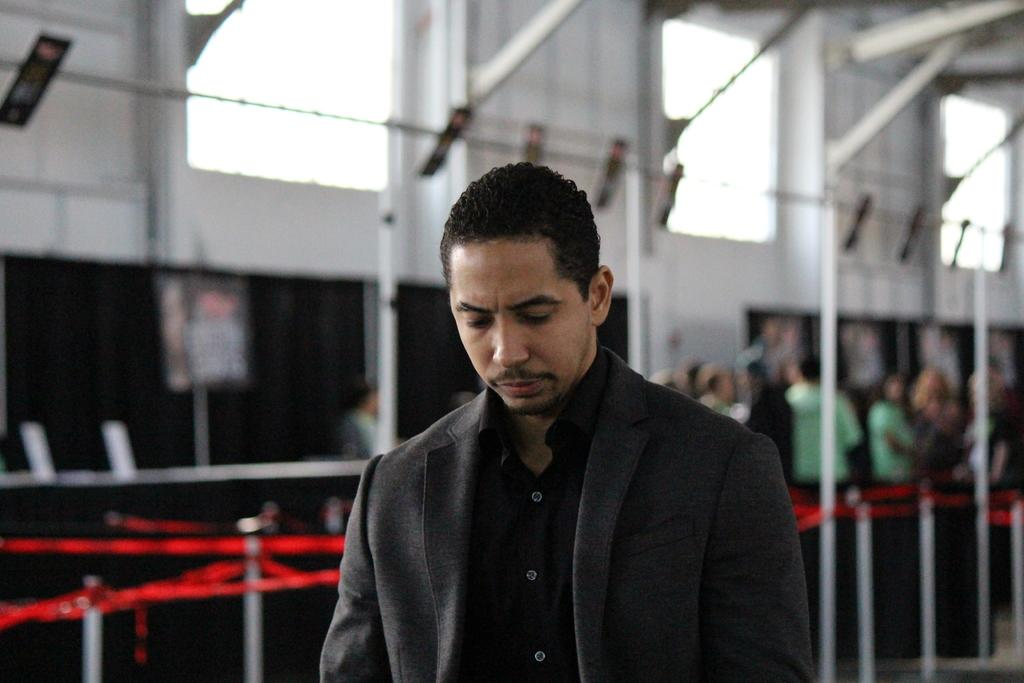What is the man in the image wearing? The man is wearing a blazer in the image. What can be seen in the background of the image? There are windows, a wall, a rod, ribbons with a fence, a group of people with green T-shirts, and people wearing black color dresses in the background of the image. What type of animal is the expert folding in the image? There is no animal or expert present in the image, and therefore no such activity can be observed. 